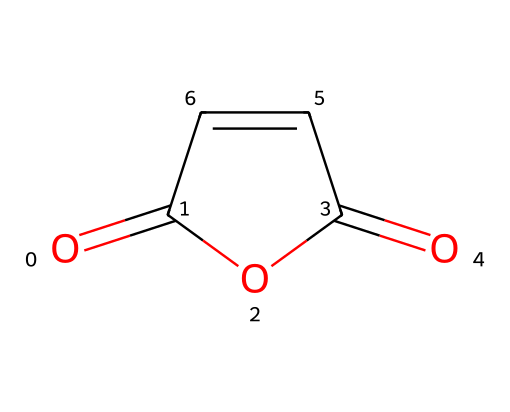What is the name of the chemical represented? The structure corresponds to maleic anhydride due to the presence of the cyclic anhydride functional group and the specific arrangement of carbon and oxygen atoms.
Answer: maleic anhydride How many carbon atoms are in maleic anhydride? The SMILES representation shows a total of four carbon atoms which are denoted in the structure by 'C' in the rings and chain.
Answer: four What type of functional groups are present in maleic anhydride? The structure shows the presence of an anhydride functional group, specifically two carbonyl (C=O) groups, highlighting that it is an acid anhydride derived from maleic acid.
Answer: anhydride What is the total number of oxygen atoms in maleic anhydride? Analyzing the SMILES, there are two carbonyl oxygens and one additional oxygen in the cyclic structure, leading to a total of three oxygen atoms.
Answer: three Is maleic anhydride aromatic? The structure includes a conjugated double bond system in a cyclic arrangement, allowing it to exhibit resonance; however, it is not classified as aromatic due to lack of continuity in an uninterrupted cyclic structure with sp2 hybridization around all atoms.
Answer: no How many double bonds are present in maleic anhydride? The representation shows a total of three double bonds; two from the carbonyl groups and one from the double bond between adjacent carbons in the ring.
Answer: three What type of bonding predominates in the maleic anhydride structure? The structure displays a mix of double (C=C, C=O) and single (C-C) bonds, but the presence of multiple double bonds is characteristic of unsaturation in this compound.
Answer: covalent 